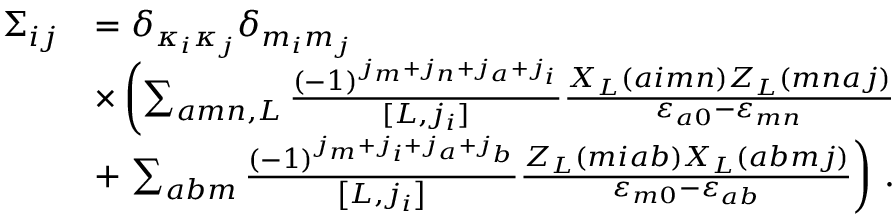<formula> <loc_0><loc_0><loc_500><loc_500>\begin{array} { r l } { \Sigma _ { i j } } & { = \delta _ { \kappa _ { i } \kappa _ { j } } \delta _ { m _ { i } m _ { j } } } \\ & { \times \left ( \sum _ { a m n , L } \frac { ( - 1 ) ^ { j _ { m } + j _ { n } + j _ { a } + j _ { i } } } { [ L , j _ { i } ] } \frac { X _ { L } ( a i m n ) Z _ { L } ( m n a j ) } { \varepsilon _ { a 0 } - \varepsilon _ { m n } } } \\ & { + \sum _ { a b m } \frac { \left ( - 1 \right ) ^ { j _ { m } + j _ { i } + j _ { a } + j _ { b } } } { \left [ L , j _ { i } \right ] } \frac { Z _ { L } \left ( m i a b \right ) X _ { L } \left ( a b m j \right ) } { \varepsilon _ { m 0 } - \varepsilon _ { a b } } \right ) \, . } \end{array}</formula> 